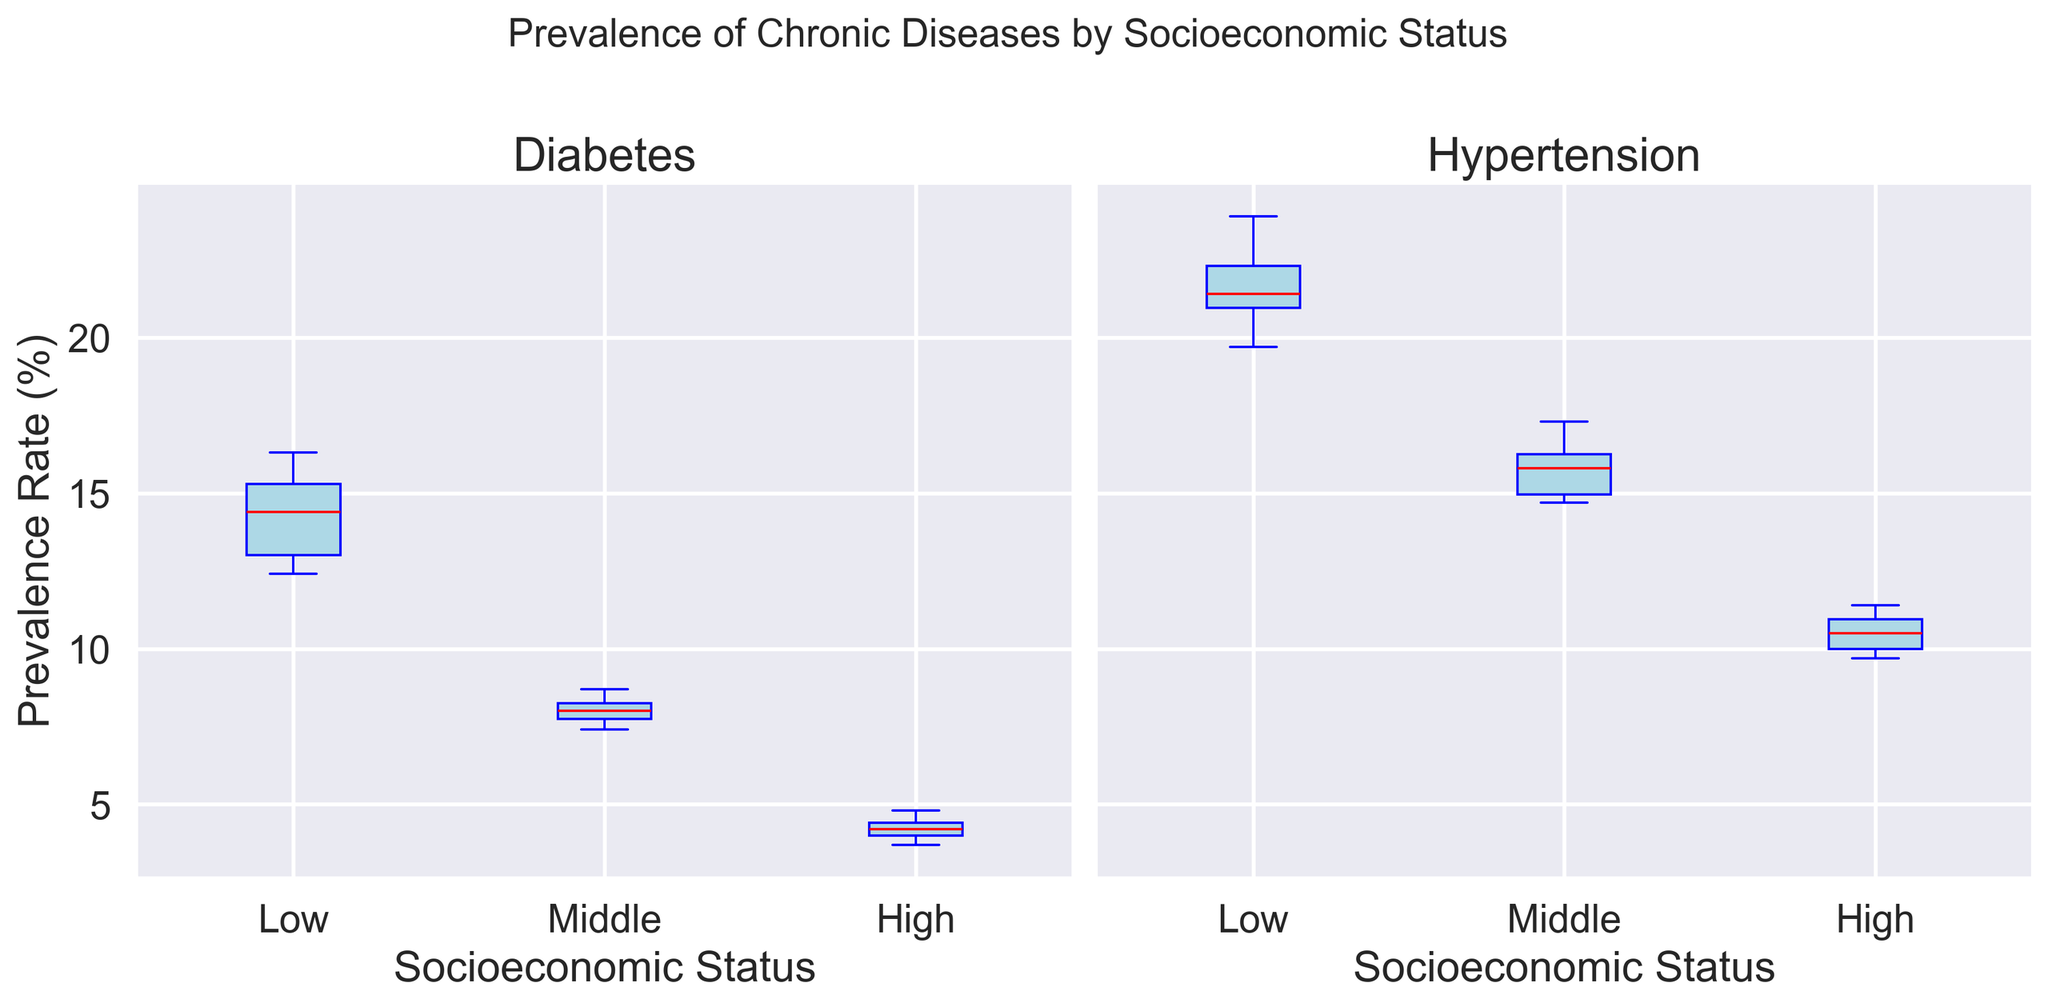What is the median prevalence rate of Diabetes among the Low socioeconomic status group? To find the median prevalence rate, look at the distribution of the Diabetes data points for the Low socioeconomic status group, sorted in ascending order: [12.4, 12.9, 13.1, 14.4, 14.7, 15.9, 16.3]. The median is the middle value, which in this case is 14.4.
Answer: 14.4 Which socioeconomic group has the highest median prevalence rate of Hypertension? Examine the median lines (red lines) within the boxes in the Hypertension subplots for all socioeconomic groups. The Low socioeconomic status group has a median higher than the Middle and High groups.
Answer: Low Is the interquartile range (IQR) for Diabetes greater in the Low socioeconomic status group compared to the High socioeconomic status group? The IQR is the range between the first quartile (Q1, the bottom of the box) and the third quartile (Q3, the top of the box). Comparing the height of the boxes for Diabetes between the Low and High groups, the box for the Low group is taller, indicating a greater IQR.
Answer: Yes What is the difference in the median prevalence rates of Diabetes between the Low and High socioeconomic status groups? From the Diabetes subplot, identify the median of the Low group (14.4) and the High group (4.2). Subtract the median of the High group from the Low group: 14.4 - 4.2.
Answer: 10.2 Which chronic disease shows a higher variability in prevalence rate among the Middle socioeconomic status group? Variability can be judged by the range between the whiskers. Looking at the boxes and whiskers for both Diabetes and Hypertension in the Middle group, Hypertension has a larger spread from minimum to maximum.
Answer: Hypertension Are there any outliers in the prevalence rates of Hypertension for the High socioeconomic status group, and how can you tell? Outliers are usually indicated by individual points outside of the whiskers. In the High socioeconomic group for Hypertension, no points are outside the whiskers, indicating no outliers.
Answer: No How does the variability in prevalence rates of Diabetes in the Middle socioeconomic status group compare to the High group? Examine the height of the boxes and length of the whiskers. The Middle group for Diabetes has a taller box and longer whiskers compared to the High group, indicating higher variability.
Answer: Higher What is the range of prevalence rates for Hypertension in the Low socioeconomic status group? Identify the smallest and largest values within the whiskers in the Hypertension subplot under the Low group. The range is the difference between these values: 23.9 - 19.7.
Answer: 4.2 How does the median prevalence rate of Hypertension in the Middle socioeconomic group compare to the Low group? Look at the red median lines in the Hypertension boxes. The Middle group's median (around 15.8) is lower than the Low group's median (around 21.4).
Answer: Lower 